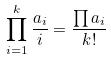Convert formula to latex. <formula><loc_0><loc_0><loc_500><loc_500>\prod _ { i = 1 } ^ { k } \frac { a _ { i } } { i } = \frac { \prod a _ { i } } { k ! }</formula> 